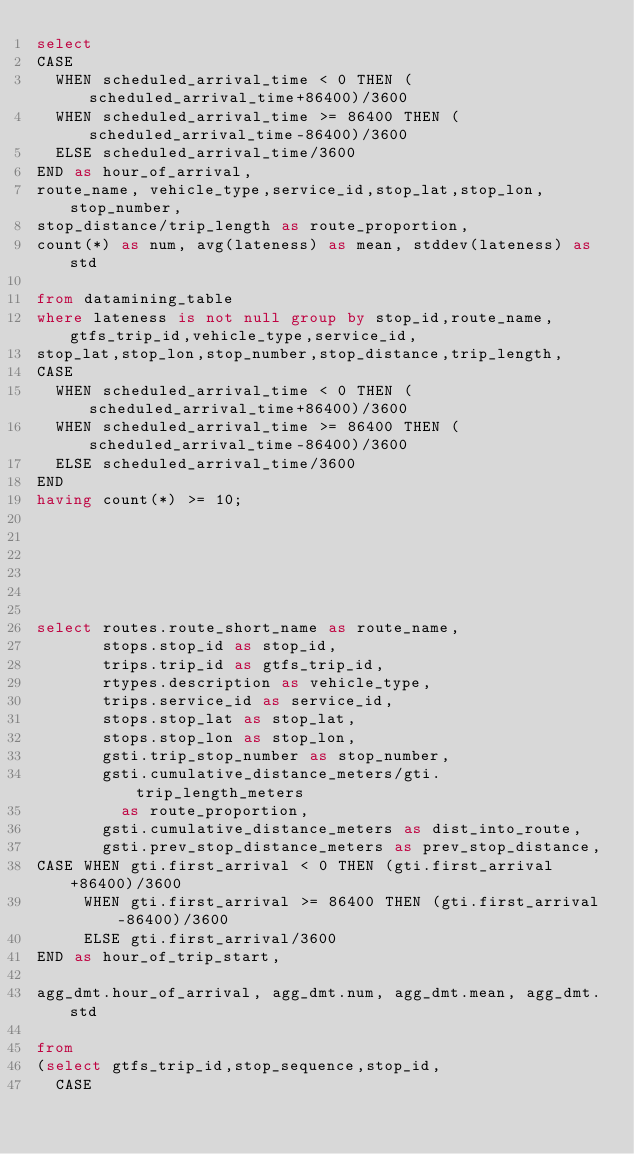Convert code to text. <code><loc_0><loc_0><loc_500><loc_500><_SQL_>select 
CASE 
  WHEN scheduled_arrival_time < 0 THEN (scheduled_arrival_time+86400)/3600
  WHEN scheduled_arrival_time >= 86400 THEN (scheduled_arrival_time-86400)/3600
  ELSE scheduled_arrival_time/3600
END as hour_of_arrival,
route_name, vehicle_type,service_id,stop_lat,stop_lon,stop_number,
stop_distance/trip_length as route_proportion,
count(*) as num, avg(lateness) as mean, stddev(lateness) as std

from datamining_table 
where lateness is not null group by stop_id,route_name,gtfs_trip_id,vehicle_type,service_id,
stop_lat,stop_lon,stop_number,stop_distance,trip_length,
CASE 
  WHEN scheduled_arrival_time < 0 THEN (scheduled_arrival_time+86400)/3600
  WHEN scheduled_arrival_time >= 86400 THEN (scheduled_arrival_time-86400)/3600
  ELSE scheduled_arrival_time/3600
END
having count(*) >= 10;






select routes.route_short_name as route_name,
       stops.stop_id as stop_id,
       trips.trip_id as gtfs_trip_id,
       rtypes.description as vehicle_type,
       trips.service_id as service_id,
       stops.stop_lat as stop_lat,
       stops.stop_lon as stop_lon,
       gsti.trip_stop_number as stop_number,
       gsti.cumulative_distance_meters/gti.trip_length_meters 
         as route_proportion,
       gsti.cumulative_distance_meters as dist_into_route,
       gsti.prev_stop_distance_meters as prev_stop_distance,
CASE WHEN gti.first_arrival < 0 THEN (gti.first_arrival+86400)/3600
     WHEN gti.first_arrival >= 86400 THEN (gti.first_arrival-86400)/3600
     ELSE gti.first_arrival/3600
END as hour_of_trip_start,

agg_dmt.hour_of_arrival, agg_dmt.num, agg_dmt.mean, agg_dmt.std

from 
(select gtfs_trip_id,stop_sequence,stop_id,
  CASE </code> 